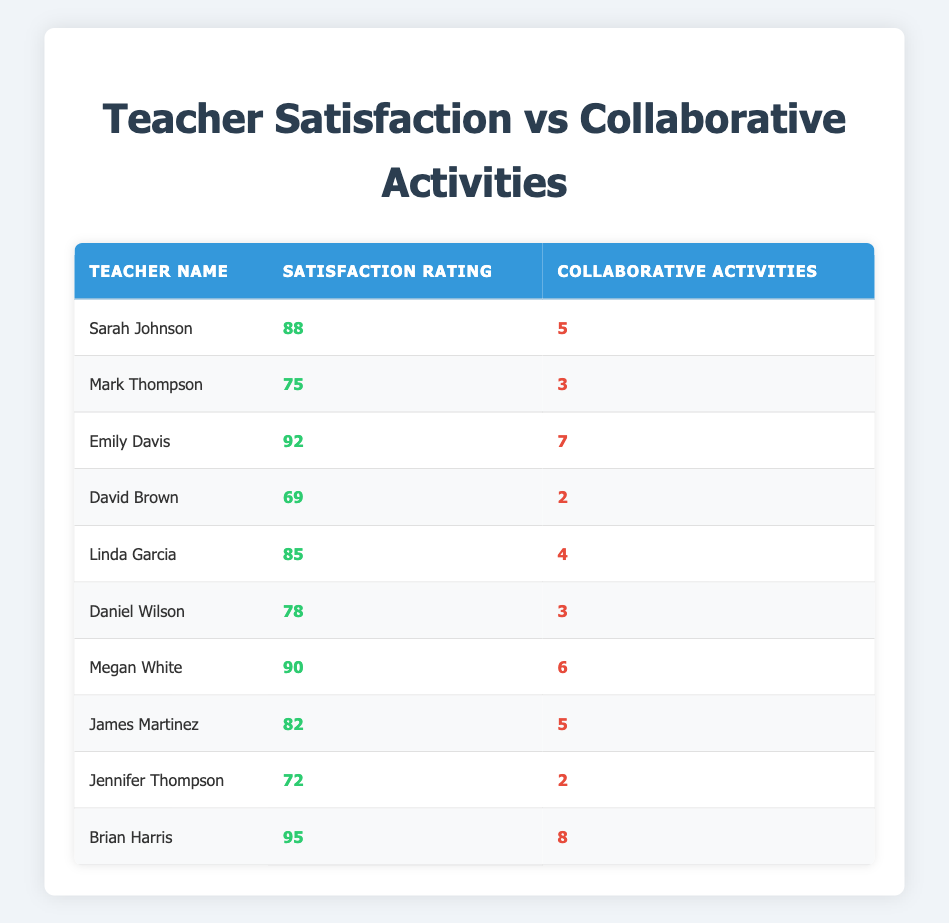What is the satisfaction rating of Brian Harris? The table lists Brian Harris's satisfaction rating as 95.
Answer: 95 How many collaborative activities did Emily Davis have? According to the table, Emily Davis participated in 7 collaborative activities.
Answer: 7 Which teacher has the lowest satisfaction rating? By examining the satisfaction ratings, David Brown has the lowest rating at 69.
Answer: David Brown What is the average satisfaction rating of all teachers listed? First, sum the satisfaction ratings: 88 + 75 + 92 + 69 + 85 + 78 + 90 + 82 + 72 + 95 =  916. There are 10 teachers, so the average is 916 / 10 = 91.6.
Answer: 91.6 Is Linda Garcia's satisfaction rating higher than Mark Thompson's? Linda Garcia has a satisfaction rating of 85, while Mark Thompson's rating is 75. Therefore, Linda's rating is higher.
Answer: Yes Which teacher had the most collaborative activities and what is their satisfaction rating? Brian Harris had the most collaborative activities with a total of 8, and his satisfaction rating is 95.
Answer: Brian Harris, 95 How many teachers participated in 4 or more collaborative activities? Counting the teachers with 4 or more activities: Sarah Johnson (5), Emily Davis (7), Megan White (6), James Martinez (5), and Brian Harris (8). This results in 5 teachers.
Answer: 5 What is the difference in satisfaction rating between the teacher with the highest and the lowest rating? Brian Harris has the highest rating at 95 and David Brown has the lowest at 69. The difference is 95 - 69 = 26.
Answer: 26 Are there any teachers with a satisfaction rating of 80 or above who participated in exactly 3 collaborative activities? The answer is no because Daniel Wilson and Mark Thompson are the only teachers with 3 activities, and their ratings are 78 and 75 respectively, both below 80.
Answer: No 